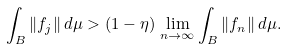Convert formula to latex. <formula><loc_0><loc_0><loc_500><loc_500>\int _ { B } \| f _ { j } \| \, d \mu > ( 1 - \eta ) \, \lim _ { n \to \infty } \int _ { B } \| f _ { n } \| \, d \mu .</formula> 